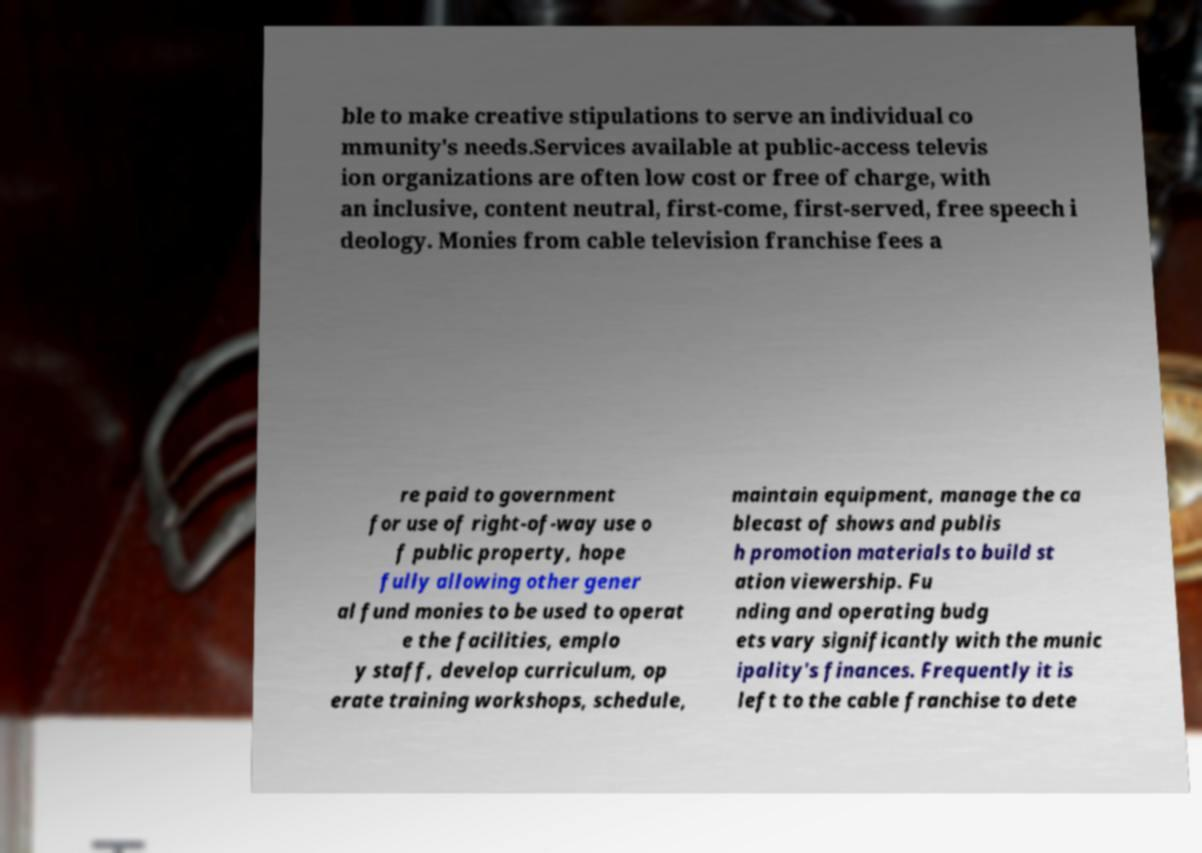For documentation purposes, I need the text within this image transcribed. Could you provide that? ble to make creative stipulations to serve an individual co mmunity's needs.Services available at public-access televis ion organizations are often low cost or free of charge, with an inclusive, content neutral, first-come, first-served, free speech i deology. Monies from cable television franchise fees a re paid to government for use of right-of-way use o f public property, hope fully allowing other gener al fund monies to be used to operat e the facilities, emplo y staff, develop curriculum, op erate training workshops, schedule, maintain equipment, manage the ca blecast of shows and publis h promotion materials to build st ation viewership. Fu nding and operating budg ets vary significantly with the munic ipality's finances. Frequently it is left to the cable franchise to dete 